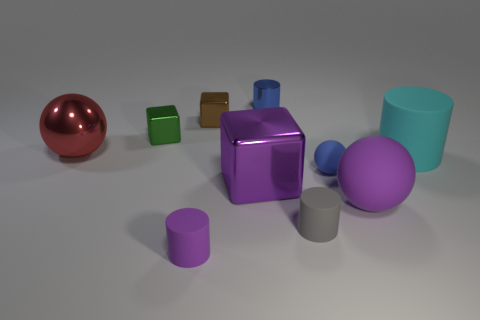What could be the context or setting of this image? The image resembles a set-up for a study in light, reflections, and geometry, perhaps in a context like a 3D modeling software or a visual arts demonstration. Is there any indication of movement or dynamism in the scene? The objects are stationary, but the varying reflections and shadows on the surfaces create a dynamic interplay of light, giving a sense of potential energy within the stillness. 